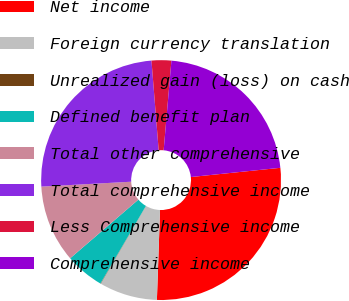Convert chart to OTSL. <chart><loc_0><loc_0><loc_500><loc_500><pie_chart><fcel>Net income<fcel>Foreign currency translation<fcel>Unrealized gain (loss) on cash<fcel>Defined benefit plan<fcel>Total other comprehensive<fcel>Total comprehensive income<fcel>Less Comprehensive income<fcel>Comprehensive income<nl><fcel>27.19%<fcel>7.84%<fcel>0.05%<fcel>5.25%<fcel>10.44%<fcel>24.59%<fcel>2.65%<fcel>21.99%<nl></chart> 